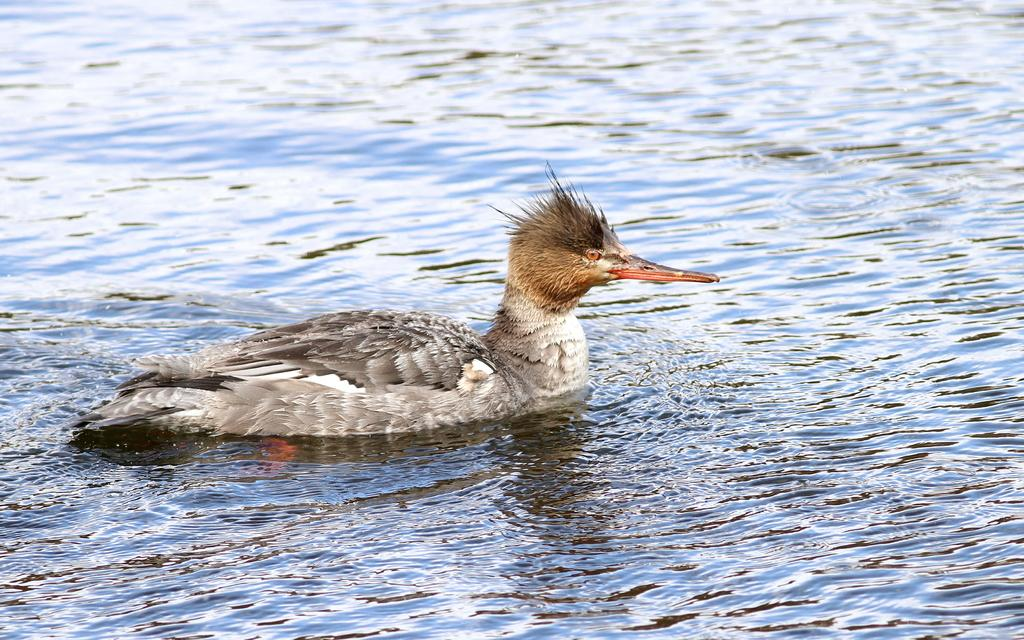What is the main subject of the image? There is a duck in the center of the image. Where is the duck located? The duck is in the water. How many stars can be seen in the image? There are no stars visible in the image, as it features a duck in the water. 